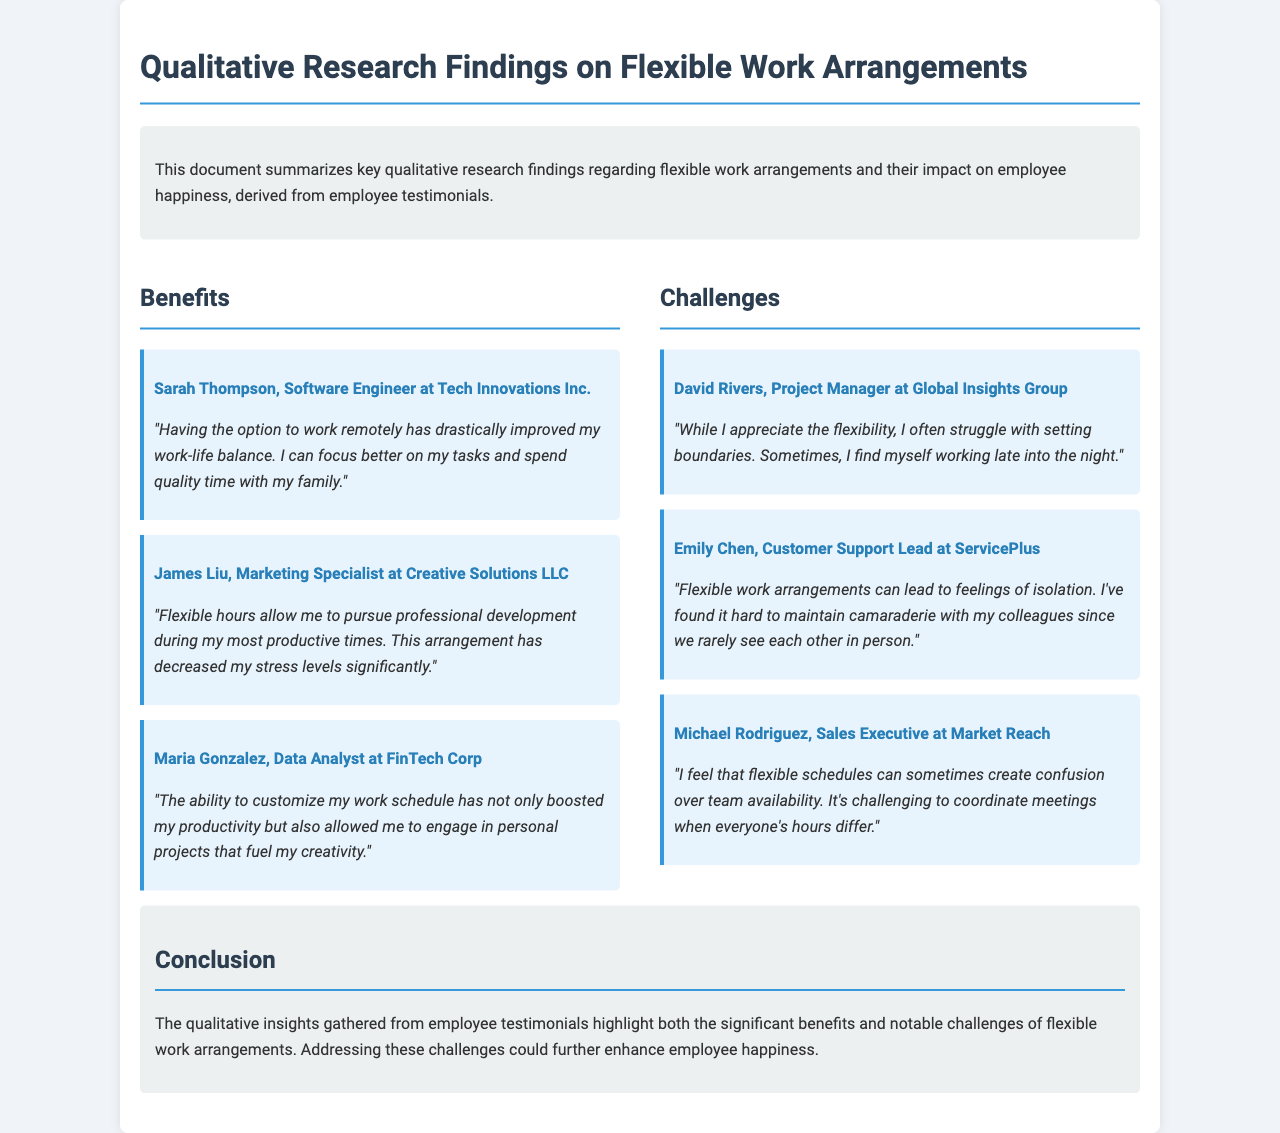what is the title of the document? The title is found in the header section of the document.
Answer: Qualitative Research Findings on Flexible Work Arrangements who is the author of the first testimonial? The name of the first employee providing a testimonial is mentioned at the beginning of the testimonial section.
Answer: Sarah Thompson how many testimonials are listed under benefits? The number of testimonials can be counted in the benefits section of the document.
Answer: 3 what challenge does David Rivers mention in his testimonial? The challenge he mentions is detailed in his statement about struggle related to work boundaries.
Answer: Setting boundaries which employee emphasized the impact of flexible hours on stress levels? This information is found in the testimonial that discusses reduced stress due to flexible hours.
Answer: James Liu what color scheme is used for the testimonials? The color scheme is mentioned in the styling of the testimonials.
Answer: Light blue what are the two main sections of findings highlighted in the document? These sections are clearly outlined in the findings layout of the document.
Answer: Benefits and Challenges what does the conclusion suggest may enhance employee happiness? The conclusion provides insight into potential improvements from addressing mentioned challenges.
Answer: Addressing challenges 